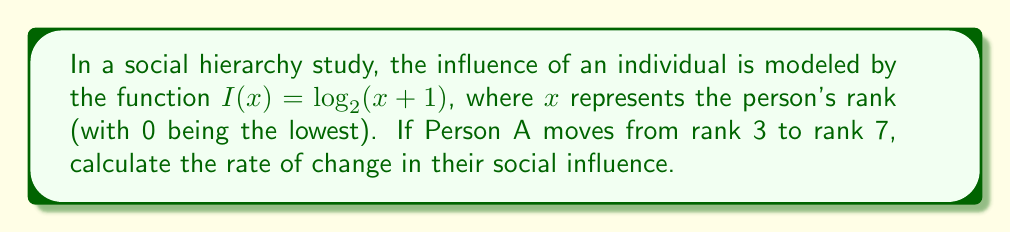Provide a solution to this math problem. To solve this problem, we need to follow these steps:

1) First, let's calculate the influence at rank 3:
   $I(3) = \log_2(3+1) = \log_2(4) = 2$

2) Now, calculate the influence at rank 7:
   $I(7) = \log_2(7+1) = \log_2(8) = 3$

3) The change in influence is:
   $\Delta I = I(7) - I(3) = 3 - 2 = 1$

4) The change in rank is:
   $\Delta x = 7 - 3 = 4$

5) The rate of change is the change in influence divided by the change in rank:
   Rate of change = $\frac{\Delta I}{\Delta x} = \frac{1}{4} = 0.25$

Therefore, the rate of change in social influence as Person A moves from rank 3 to rank 7 is 0.25 units of influence per rank.
Answer: 0.25 units of influence per rank 